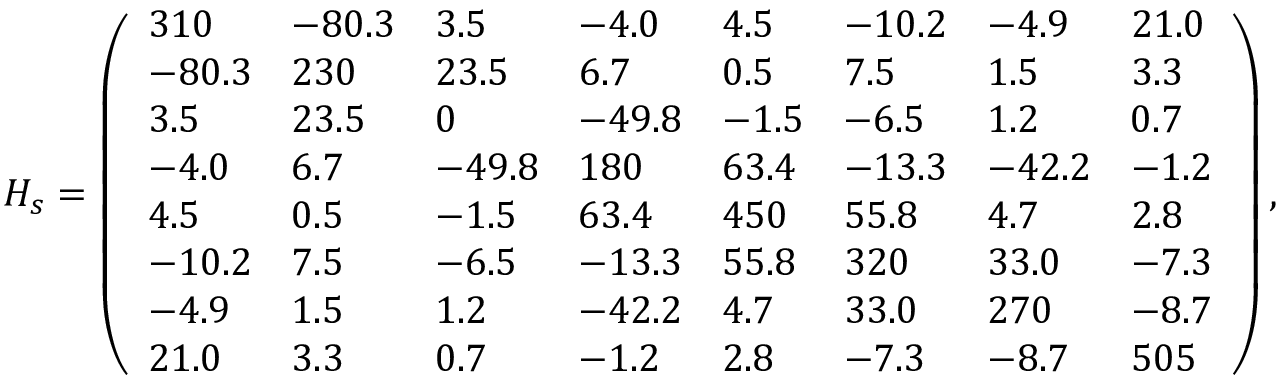<formula> <loc_0><loc_0><loc_500><loc_500>H _ { s } = \left ( \begin{array} { l l l l l l l l } { 3 1 0 } & { - 8 0 . 3 } & { 3 . 5 } & { - 4 . 0 } & { 4 . 5 } & { - 1 0 . 2 } & { - 4 . 9 } & { 2 1 . 0 } \\ { - 8 0 . 3 } & { 2 3 0 } & { 2 3 . 5 } & { 6 . 7 } & { 0 . 5 } & { 7 . 5 } & { 1 . 5 } & { 3 . 3 } \\ { 3 . 5 } & { 2 3 . 5 } & { 0 } & { - 4 9 . 8 } & { - 1 . 5 } & { - 6 . 5 } & { 1 . 2 } & { 0 . 7 } \\ { - 4 . 0 } & { 6 . 7 } & { - 4 9 . 8 } & { 1 8 0 } & { 6 3 . 4 } & { - 1 3 . 3 } & { - 4 2 . 2 } & { - 1 . 2 } \\ { 4 . 5 } & { 0 . 5 } & { - 1 . 5 } & { 6 3 . 4 } & { 4 5 0 } & { 5 5 . 8 } & { 4 . 7 } & { 2 . 8 } \\ { - 1 0 . 2 } & { 7 . 5 } & { - 6 . 5 } & { - 1 3 . 3 } & { 5 5 . 8 } & { 3 2 0 } & { 3 3 . 0 } & { - 7 . 3 } \\ { - 4 . 9 } & { 1 . 5 } & { 1 . 2 } & { - 4 2 . 2 } & { 4 . 7 } & { 3 3 . 0 } & { 2 7 0 } & { - 8 . 7 } \\ { 2 1 . 0 } & { 3 . 3 } & { 0 . 7 } & { - 1 . 2 } & { 2 . 8 } & { - 7 . 3 } & { - 8 . 7 } & { 5 0 5 } \end{array} \right ) ,</formula> 